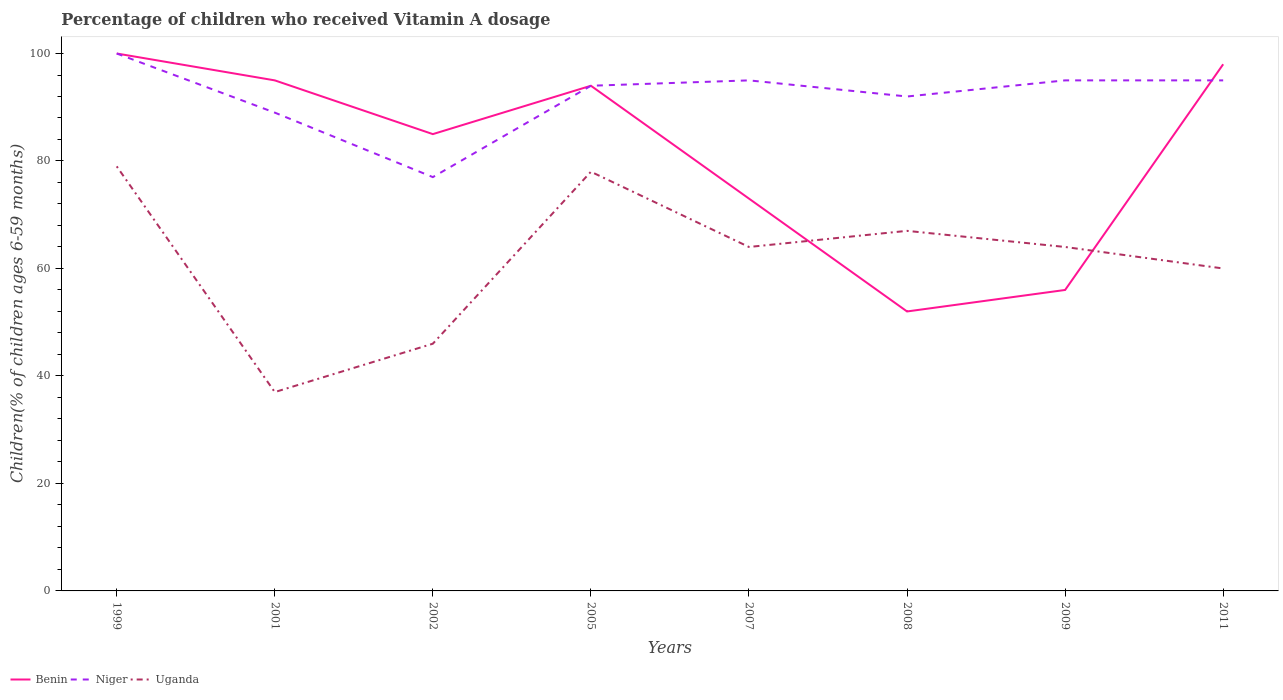How many different coloured lines are there?
Provide a succinct answer. 3. Does the line corresponding to Niger intersect with the line corresponding to Uganda?
Give a very brief answer. No. Is the number of lines equal to the number of legend labels?
Ensure brevity in your answer.  Yes. In which year was the percentage of children who received Vitamin A dosage in Niger maximum?
Ensure brevity in your answer.  2002. How many lines are there?
Your answer should be very brief. 3. How many years are there in the graph?
Offer a terse response. 8. Does the graph contain any zero values?
Your answer should be compact. No. Does the graph contain grids?
Provide a succinct answer. No. How are the legend labels stacked?
Make the answer very short. Horizontal. What is the title of the graph?
Make the answer very short. Percentage of children who received Vitamin A dosage. Does "Chad" appear as one of the legend labels in the graph?
Give a very brief answer. No. What is the label or title of the Y-axis?
Provide a short and direct response. Children(% of children ages 6-59 months). What is the Children(% of children ages 6-59 months) of Benin in 1999?
Your answer should be compact. 100. What is the Children(% of children ages 6-59 months) of Uganda in 1999?
Offer a very short reply. 79. What is the Children(% of children ages 6-59 months) of Benin in 2001?
Offer a very short reply. 95. What is the Children(% of children ages 6-59 months) in Niger in 2001?
Offer a terse response. 89. What is the Children(% of children ages 6-59 months) of Uganda in 2001?
Make the answer very short. 37. What is the Children(% of children ages 6-59 months) in Benin in 2002?
Keep it short and to the point. 85. What is the Children(% of children ages 6-59 months) of Niger in 2002?
Offer a very short reply. 77. What is the Children(% of children ages 6-59 months) in Benin in 2005?
Give a very brief answer. 94. What is the Children(% of children ages 6-59 months) of Niger in 2005?
Provide a short and direct response. 94. What is the Children(% of children ages 6-59 months) in Benin in 2007?
Offer a terse response. 73. What is the Children(% of children ages 6-59 months) of Niger in 2008?
Your answer should be compact. 92. What is the Children(% of children ages 6-59 months) in Uganda in 2008?
Your response must be concise. 67. What is the Children(% of children ages 6-59 months) of Benin in 2011?
Provide a short and direct response. 98. What is the Children(% of children ages 6-59 months) in Niger in 2011?
Offer a very short reply. 95. Across all years, what is the maximum Children(% of children ages 6-59 months) in Benin?
Offer a terse response. 100. Across all years, what is the maximum Children(% of children ages 6-59 months) of Niger?
Your answer should be very brief. 100. Across all years, what is the maximum Children(% of children ages 6-59 months) of Uganda?
Offer a terse response. 79. Across all years, what is the minimum Children(% of children ages 6-59 months) in Benin?
Keep it short and to the point. 52. Across all years, what is the minimum Children(% of children ages 6-59 months) in Niger?
Give a very brief answer. 77. What is the total Children(% of children ages 6-59 months) in Benin in the graph?
Your answer should be very brief. 653. What is the total Children(% of children ages 6-59 months) of Niger in the graph?
Ensure brevity in your answer.  737. What is the total Children(% of children ages 6-59 months) in Uganda in the graph?
Keep it short and to the point. 495. What is the difference between the Children(% of children ages 6-59 months) of Benin in 1999 and that in 2001?
Ensure brevity in your answer.  5. What is the difference between the Children(% of children ages 6-59 months) in Niger in 1999 and that in 2002?
Offer a very short reply. 23. What is the difference between the Children(% of children ages 6-59 months) of Niger in 1999 and that in 2005?
Ensure brevity in your answer.  6. What is the difference between the Children(% of children ages 6-59 months) of Uganda in 1999 and that in 2007?
Your answer should be compact. 15. What is the difference between the Children(% of children ages 6-59 months) in Niger in 1999 and that in 2008?
Give a very brief answer. 8. What is the difference between the Children(% of children ages 6-59 months) in Uganda in 1999 and that in 2008?
Make the answer very short. 12. What is the difference between the Children(% of children ages 6-59 months) in Niger in 1999 and that in 2009?
Your answer should be very brief. 5. What is the difference between the Children(% of children ages 6-59 months) of Niger in 1999 and that in 2011?
Provide a succinct answer. 5. What is the difference between the Children(% of children ages 6-59 months) of Uganda in 1999 and that in 2011?
Your answer should be very brief. 19. What is the difference between the Children(% of children ages 6-59 months) in Uganda in 2001 and that in 2005?
Provide a short and direct response. -41. What is the difference between the Children(% of children ages 6-59 months) in Benin in 2001 and that in 2007?
Ensure brevity in your answer.  22. What is the difference between the Children(% of children ages 6-59 months) in Niger in 2001 and that in 2007?
Make the answer very short. -6. What is the difference between the Children(% of children ages 6-59 months) of Benin in 2001 and that in 2008?
Provide a succinct answer. 43. What is the difference between the Children(% of children ages 6-59 months) of Niger in 2001 and that in 2008?
Your response must be concise. -3. What is the difference between the Children(% of children ages 6-59 months) of Benin in 2001 and that in 2009?
Provide a succinct answer. 39. What is the difference between the Children(% of children ages 6-59 months) in Niger in 2001 and that in 2009?
Offer a terse response. -6. What is the difference between the Children(% of children ages 6-59 months) of Uganda in 2001 and that in 2009?
Provide a short and direct response. -27. What is the difference between the Children(% of children ages 6-59 months) in Uganda in 2001 and that in 2011?
Ensure brevity in your answer.  -23. What is the difference between the Children(% of children ages 6-59 months) of Niger in 2002 and that in 2005?
Your answer should be compact. -17. What is the difference between the Children(% of children ages 6-59 months) of Uganda in 2002 and that in 2005?
Provide a short and direct response. -32. What is the difference between the Children(% of children ages 6-59 months) of Benin in 2002 and that in 2007?
Your response must be concise. 12. What is the difference between the Children(% of children ages 6-59 months) of Uganda in 2002 and that in 2007?
Keep it short and to the point. -18. What is the difference between the Children(% of children ages 6-59 months) of Niger in 2002 and that in 2008?
Provide a succinct answer. -15. What is the difference between the Children(% of children ages 6-59 months) of Uganda in 2002 and that in 2008?
Offer a very short reply. -21. What is the difference between the Children(% of children ages 6-59 months) of Benin in 2002 and that in 2009?
Offer a very short reply. 29. What is the difference between the Children(% of children ages 6-59 months) in Benin in 2002 and that in 2011?
Your answer should be very brief. -13. What is the difference between the Children(% of children ages 6-59 months) in Niger in 2002 and that in 2011?
Provide a short and direct response. -18. What is the difference between the Children(% of children ages 6-59 months) of Uganda in 2002 and that in 2011?
Ensure brevity in your answer.  -14. What is the difference between the Children(% of children ages 6-59 months) in Niger in 2005 and that in 2007?
Keep it short and to the point. -1. What is the difference between the Children(% of children ages 6-59 months) in Uganda in 2005 and that in 2007?
Offer a terse response. 14. What is the difference between the Children(% of children ages 6-59 months) in Benin in 2005 and that in 2008?
Your answer should be very brief. 42. What is the difference between the Children(% of children ages 6-59 months) of Niger in 2005 and that in 2008?
Provide a succinct answer. 2. What is the difference between the Children(% of children ages 6-59 months) in Uganda in 2005 and that in 2009?
Offer a terse response. 14. What is the difference between the Children(% of children ages 6-59 months) in Benin in 2005 and that in 2011?
Offer a very short reply. -4. What is the difference between the Children(% of children ages 6-59 months) in Uganda in 2005 and that in 2011?
Your answer should be very brief. 18. What is the difference between the Children(% of children ages 6-59 months) in Niger in 2008 and that in 2009?
Your answer should be compact. -3. What is the difference between the Children(% of children ages 6-59 months) in Uganda in 2008 and that in 2009?
Your answer should be compact. 3. What is the difference between the Children(% of children ages 6-59 months) in Benin in 2008 and that in 2011?
Provide a succinct answer. -46. What is the difference between the Children(% of children ages 6-59 months) of Niger in 2008 and that in 2011?
Ensure brevity in your answer.  -3. What is the difference between the Children(% of children ages 6-59 months) of Benin in 2009 and that in 2011?
Your response must be concise. -42. What is the difference between the Children(% of children ages 6-59 months) in Uganda in 2009 and that in 2011?
Offer a very short reply. 4. What is the difference between the Children(% of children ages 6-59 months) of Benin in 1999 and the Children(% of children ages 6-59 months) of Uganda in 2001?
Offer a very short reply. 63. What is the difference between the Children(% of children ages 6-59 months) of Benin in 1999 and the Children(% of children ages 6-59 months) of Niger in 2002?
Offer a terse response. 23. What is the difference between the Children(% of children ages 6-59 months) in Benin in 1999 and the Children(% of children ages 6-59 months) in Uganda in 2002?
Your answer should be compact. 54. What is the difference between the Children(% of children ages 6-59 months) in Niger in 1999 and the Children(% of children ages 6-59 months) in Uganda in 2002?
Your response must be concise. 54. What is the difference between the Children(% of children ages 6-59 months) of Benin in 1999 and the Children(% of children ages 6-59 months) of Uganda in 2005?
Ensure brevity in your answer.  22. What is the difference between the Children(% of children ages 6-59 months) in Niger in 1999 and the Children(% of children ages 6-59 months) in Uganda in 2005?
Your answer should be compact. 22. What is the difference between the Children(% of children ages 6-59 months) of Benin in 1999 and the Children(% of children ages 6-59 months) of Niger in 2007?
Give a very brief answer. 5. What is the difference between the Children(% of children ages 6-59 months) in Niger in 1999 and the Children(% of children ages 6-59 months) in Uganda in 2007?
Make the answer very short. 36. What is the difference between the Children(% of children ages 6-59 months) of Benin in 1999 and the Children(% of children ages 6-59 months) of Uganda in 2008?
Provide a short and direct response. 33. What is the difference between the Children(% of children ages 6-59 months) in Benin in 1999 and the Children(% of children ages 6-59 months) in Uganda in 2009?
Your response must be concise. 36. What is the difference between the Children(% of children ages 6-59 months) of Niger in 1999 and the Children(% of children ages 6-59 months) of Uganda in 2009?
Your answer should be very brief. 36. What is the difference between the Children(% of children ages 6-59 months) in Benin in 1999 and the Children(% of children ages 6-59 months) in Uganda in 2011?
Provide a succinct answer. 40. What is the difference between the Children(% of children ages 6-59 months) in Niger in 1999 and the Children(% of children ages 6-59 months) in Uganda in 2011?
Your answer should be very brief. 40. What is the difference between the Children(% of children ages 6-59 months) of Niger in 2001 and the Children(% of children ages 6-59 months) of Uganda in 2002?
Make the answer very short. 43. What is the difference between the Children(% of children ages 6-59 months) in Benin in 2001 and the Children(% of children ages 6-59 months) in Niger in 2005?
Give a very brief answer. 1. What is the difference between the Children(% of children ages 6-59 months) in Niger in 2001 and the Children(% of children ages 6-59 months) in Uganda in 2005?
Offer a very short reply. 11. What is the difference between the Children(% of children ages 6-59 months) of Benin in 2001 and the Children(% of children ages 6-59 months) of Niger in 2007?
Ensure brevity in your answer.  0. What is the difference between the Children(% of children ages 6-59 months) of Benin in 2001 and the Children(% of children ages 6-59 months) of Uganda in 2007?
Your answer should be compact. 31. What is the difference between the Children(% of children ages 6-59 months) of Benin in 2001 and the Children(% of children ages 6-59 months) of Uganda in 2008?
Your response must be concise. 28. What is the difference between the Children(% of children ages 6-59 months) in Benin in 2001 and the Children(% of children ages 6-59 months) in Niger in 2011?
Offer a terse response. 0. What is the difference between the Children(% of children ages 6-59 months) in Benin in 2002 and the Children(% of children ages 6-59 months) in Niger in 2005?
Your answer should be compact. -9. What is the difference between the Children(% of children ages 6-59 months) in Benin in 2002 and the Children(% of children ages 6-59 months) in Uganda in 2005?
Your response must be concise. 7. What is the difference between the Children(% of children ages 6-59 months) in Benin in 2002 and the Children(% of children ages 6-59 months) in Uganda in 2007?
Provide a succinct answer. 21. What is the difference between the Children(% of children ages 6-59 months) in Benin in 2002 and the Children(% of children ages 6-59 months) in Niger in 2008?
Your answer should be very brief. -7. What is the difference between the Children(% of children ages 6-59 months) in Niger in 2002 and the Children(% of children ages 6-59 months) in Uganda in 2008?
Keep it short and to the point. 10. What is the difference between the Children(% of children ages 6-59 months) of Benin in 2002 and the Children(% of children ages 6-59 months) of Niger in 2009?
Provide a succinct answer. -10. What is the difference between the Children(% of children ages 6-59 months) in Benin in 2002 and the Children(% of children ages 6-59 months) in Uganda in 2009?
Give a very brief answer. 21. What is the difference between the Children(% of children ages 6-59 months) of Niger in 2002 and the Children(% of children ages 6-59 months) of Uganda in 2009?
Make the answer very short. 13. What is the difference between the Children(% of children ages 6-59 months) in Benin in 2002 and the Children(% of children ages 6-59 months) in Uganda in 2011?
Offer a terse response. 25. What is the difference between the Children(% of children ages 6-59 months) of Benin in 2005 and the Children(% of children ages 6-59 months) of Niger in 2008?
Ensure brevity in your answer.  2. What is the difference between the Children(% of children ages 6-59 months) of Benin in 2005 and the Children(% of children ages 6-59 months) of Niger in 2009?
Keep it short and to the point. -1. What is the difference between the Children(% of children ages 6-59 months) in Benin in 2005 and the Children(% of children ages 6-59 months) in Uganda in 2011?
Offer a very short reply. 34. What is the difference between the Children(% of children ages 6-59 months) in Benin in 2007 and the Children(% of children ages 6-59 months) in Uganda in 2008?
Keep it short and to the point. 6. What is the difference between the Children(% of children ages 6-59 months) in Niger in 2007 and the Children(% of children ages 6-59 months) in Uganda in 2008?
Your answer should be compact. 28. What is the difference between the Children(% of children ages 6-59 months) in Benin in 2007 and the Children(% of children ages 6-59 months) in Niger in 2009?
Make the answer very short. -22. What is the difference between the Children(% of children ages 6-59 months) in Benin in 2007 and the Children(% of children ages 6-59 months) in Uganda in 2011?
Provide a short and direct response. 13. What is the difference between the Children(% of children ages 6-59 months) in Benin in 2008 and the Children(% of children ages 6-59 months) in Niger in 2009?
Make the answer very short. -43. What is the difference between the Children(% of children ages 6-59 months) in Niger in 2008 and the Children(% of children ages 6-59 months) in Uganda in 2009?
Your answer should be compact. 28. What is the difference between the Children(% of children ages 6-59 months) of Benin in 2008 and the Children(% of children ages 6-59 months) of Niger in 2011?
Your answer should be very brief. -43. What is the difference between the Children(% of children ages 6-59 months) in Benin in 2008 and the Children(% of children ages 6-59 months) in Uganda in 2011?
Your answer should be very brief. -8. What is the difference between the Children(% of children ages 6-59 months) in Benin in 2009 and the Children(% of children ages 6-59 months) in Niger in 2011?
Provide a succinct answer. -39. What is the difference between the Children(% of children ages 6-59 months) of Benin in 2009 and the Children(% of children ages 6-59 months) of Uganda in 2011?
Offer a terse response. -4. What is the average Children(% of children ages 6-59 months) in Benin per year?
Make the answer very short. 81.62. What is the average Children(% of children ages 6-59 months) in Niger per year?
Ensure brevity in your answer.  92.12. What is the average Children(% of children ages 6-59 months) of Uganda per year?
Make the answer very short. 61.88. In the year 1999, what is the difference between the Children(% of children ages 6-59 months) of Benin and Children(% of children ages 6-59 months) of Uganda?
Your answer should be compact. 21. In the year 2001, what is the difference between the Children(% of children ages 6-59 months) of Benin and Children(% of children ages 6-59 months) of Uganda?
Keep it short and to the point. 58. In the year 2002, what is the difference between the Children(% of children ages 6-59 months) in Benin and Children(% of children ages 6-59 months) in Niger?
Your answer should be very brief. 8. In the year 2005, what is the difference between the Children(% of children ages 6-59 months) of Benin and Children(% of children ages 6-59 months) of Niger?
Keep it short and to the point. 0. In the year 2008, what is the difference between the Children(% of children ages 6-59 months) of Niger and Children(% of children ages 6-59 months) of Uganda?
Your answer should be compact. 25. In the year 2009, what is the difference between the Children(% of children ages 6-59 months) of Benin and Children(% of children ages 6-59 months) of Niger?
Your response must be concise. -39. In the year 2009, what is the difference between the Children(% of children ages 6-59 months) of Benin and Children(% of children ages 6-59 months) of Uganda?
Ensure brevity in your answer.  -8. In the year 2011, what is the difference between the Children(% of children ages 6-59 months) of Benin and Children(% of children ages 6-59 months) of Uganda?
Offer a terse response. 38. What is the ratio of the Children(% of children ages 6-59 months) in Benin in 1999 to that in 2001?
Your answer should be very brief. 1.05. What is the ratio of the Children(% of children ages 6-59 months) in Niger in 1999 to that in 2001?
Make the answer very short. 1.12. What is the ratio of the Children(% of children ages 6-59 months) of Uganda in 1999 to that in 2001?
Your response must be concise. 2.14. What is the ratio of the Children(% of children ages 6-59 months) of Benin in 1999 to that in 2002?
Provide a succinct answer. 1.18. What is the ratio of the Children(% of children ages 6-59 months) in Niger in 1999 to that in 2002?
Your response must be concise. 1.3. What is the ratio of the Children(% of children ages 6-59 months) of Uganda in 1999 to that in 2002?
Your response must be concise. 1.72. What is the ratio of the Children(% of children ages 6-59 months) in Benin in 1999 to that in 2005?
Ensure brevity in your answer.  1.06. What is the ratio of the Children(% of children ages 6-59 months) of Niger in 1999 to that in 2005?
Give a very brief answer. 1.06. What is the ratio of the Children(% of children ages 6-59 months) in Uganda in 1999 to that in 2005?
Keep it short and to the point. 1.01. What is the ratio of the Children(% of children ages 6-59 months) of Benin in 1999 to that in 2007?
Make the answer very short. 1.37. What is the ratio of the Children(% of children ages 6-59 months) in Niger in 1999 to that in 2007?
Offer a very short reply. 1.05. What is the ratio of the Children(% of children ages 6-59 months) of Uganda in 1999 to that in 2007?
Give a very brief answer. 1.23. What is the ratio of the Children(% of children ages 6-59 months) of Benin in 1999 to that in 2008?
Provide a short and direct response. 1.92. What is the ratio of the Children(% of children ages 6-59 months) in Niger in 1999 to that in 2008?
Offer a very short reply. 1.09. What is the ratio of the Children(% of children ages 6-59 months) in Uganda in 1999 to that in 2008?
Your response must be concise. 1.18. What is the ratio of the Children(% of children ages 6-59 months) of Benin in 1999 to that in 2009?
Ensure brevity in your answer.  1.79. What is the ratio of the Children(% of children ages 6-59 months) of Niger in 1999 to that in 2009?
Ensure brevity in your answer.  1.05. What is the ratio of the Children(% of children ages 6-59 months) of Uganda in 1999 to that in 2009?
Your answer should be very brief. 1.23. What is the ratio of the Children(% of children ages 6-59 months) of Benin in 1999 to that in 2011?
Give a very brief answer. 1.02. What is the ratio of the Children(% of children ages 6-59 months) of Niger in 1999 to that in 2011?
Your answer should be compact. 1.05. What is the ratio of the Children(% of children ages 6-59 months) of Uganda in 1999 to that in 2011?
Provide a short and direct response. 1.32. What is the ratio of the Children(% of children ages 6-59 months) in Benin in 2001 to that in 2002?
Ensure brevity in your answer.  1.12. What is the ratio of the Children(% of children ages 6-59 months) in Niger in 2001 to that in 2002?
Give a very brief answer. 1.16. What is the ratio of the Children(% of children ages 6-59 months) of Uganda in 2001 to that in 2002?
Provide a short and direct response. 0.8. What is the ratio of the Children(% of children ages 6-59 months) in Benin in 2001 to that in 2005?
Keep it short and to the point. 1.01. What is the ratio of the Children(% of children ages 6-59 months) in Niger in 2001 to that in 2005?
Provide a short and direct response. 0.95. What is the ratio of the Children(% of children ages 6-59 months) of Uganda in 2001 to that in 2005?
Keep it short and to the point. 0.47. What is the ratio of the Children(% of children ages 6-59 months) of Benin in 2001 to that in 2007?
Keep it short and to the point. 1.3. What is the ratio of the Children(% of children ages 6-59 months) in Niger in 2001 to that in 2007?
Offer a terse response. 0.94. What is the ratio of the Children(% of children ages 6-59 months) in Uganda in 2001 to that in 2007?
Offer a very short reply. 0.58. What is the ratio of the Children(% of children ages 6-59 months) in Benin in 2001 to that in 2008?
Offer a terse response. 1.83. What is the ratio of the Children(% of children ages 6-59 months) in Niger in 2001 to that in 2008?
Give a very brief answer. 0.97. What is the ratio of the Children(% of children ages 6-59 months) of Uganda in 2001 to that in 2008?
Your answer should be very brief. 0.55. What is the ratio of the Children(% of children ages 6-59 months) of Benin in 2001 to that in 2009?
Your response must be concise. 1.7. What is the ratio of the Children(% of children ages 6-59 months) in Niger in 2001 to that in 2009?
Provide a succinct answer. 0.94. What is the ratio of the Children(% of children ages 6-59 months) of Uganda in 2001 to that in 2009?
Offer a very short reply. 0.58. What is the ratio of the Children(% of children ages 6-59 months) of Benin in 2001 to that in 2011?
Offer a very short reply. 0.97. What is the ratio of the Children(% of children ages 6-59 months) of Niger in 2001 to that in 2011?
Offer a terse response. 0.94. What is the ratio of the Children(% of children ages 6-59 months) in Uganda in 2001 to that in 2011?
Provide a short and direct response. 0.62. What is the ratio of the Children(% of children ages 6-59 months) in Benin in 2002 to that in 2005?
Make the answer very short. 0.9. What is the ratio of the Children(% of children ages 6-59 months) in Niger in 2002 to that in 2005?
Provide a succinct answer. 0.82. What is the ratio of the Children(% of children ages 6-59 months) of Uganda in 2002 to that in 2005?
Make the answer very short. 0.59. What is the ratio of the Children(% of children ages 6-59 months) in Benin in 2002 to that in 2007?
Keep it short and to the point. 1.16. What is the ratio of the Children(% of children ages 6-59 months) of Niger in 2002 to that in 2007?
Offer a very short reply. 0.81. What is the ratio of the Children(% of children ages 6-59 months) in Uganda in 2002 to that in 2007?
Ensure brevity in your answer.  0.72. What is the ratio of the Children(% of children ages 6-59 months) of Benin in 2002 to that in 2008?
Offer a very short reply. 1.63. What is the ratio of the Children(% of children ages 6-59 months) in Niger in 2002 to that in 2008?
Make the answer very short. 0.84. What is the ratio of the Children(% of children ages 6-59 months) of Uganda in 2002 to that in 2008?
Your answer should be very brief. 0.69. What is the ratio of the Children(% of children ages 6-59 months) of Benin in 2002 to that in 2009?
Your response must be concise. 1.52. What is the ratio of the Children(% of children ages 6-59 months) of Niger in 2002 to that in 2009?
Keep it short and to the point. 0.81. What is the ratio of the Children(% of children ages 6-59 months) of Uganda in 2002 to that in 2009?
Provide a succinct answer. 0.72. What is the ratio of the Children(% of children ages 6-59 months) of Benin in 2002 to that in 2011?
Give a very brief answer. 0.87. What is the ratio of the Children(% of children ages 6-59 months) in Niger in 2002 to that in 2011?
Give a very brief answer. 0.81. What is the ratio of the Children(% of children ages 6-59 months) of Uganda in 2002 to that in 2011?
Your answer should be very brief. 0.77. What is the ratio of the Children(% of children ages 6-59 months) in Benin in 2005 to that in 2007?
Offer a terse response. 1.29. What is the ratio of the Children(% of children ages 6-59 months) in Uganda in 2005 to that in 2007?
Your answer should be very brief. 1.22. What is the ratio of the Children(% of children ages 6-59 months) of Benin in 2005 to that in 2008?
Your answer should be compact. 1.81. What is the ratio of the Children(% of children ages 6-59 months) in Niger in 2005 to that in 2008?
Offer a very short reply. 1.02. What is the ratio of the Children(% of children ages 6-59 months) of Uganda in 2005 to that in 2008?
Your answer should be compact. 1.16. What is the ratio of the Children(% of children ages 6-59 months) of Benin in 2005 to that in 2009?
Provide a short and direct response. 1.68. What is the ratio of the Children(% of children ages 6-59 months) in Niger in 2005 to that in 2009?
Give a very brief answer. 0.99. What is the ratio of the Children(% of children ages 6-59 months) in Uganda in 2005 to that in 2009?
Provide a short and direct response. 1.22. What is the ratio of the Children(% of children ages 6-59 months) in Benin in 2005 to that in 2011?
Give a very brief answer. 0.96. What is the ratio of the Children(% of children ages 6-59 months) of Niger in 2005 to that in 2011?
Your answer should be compact. 0.99. What is the ratio of the Children(% of children ages 6-59 months) of Benin in 2007 to that in 2008?
Provide a short and direct response. 1.4. What is the ratio of the Children(% of children ages 6-59 months) of Niger in 2007 to that in 2008?
Your answer should be compact. 1.03. What is the ratio of the Children(% of children ages 6-59 months) in Uganda in 2007 to that in 2008?
Give a very brief answer. 0.96. What is the ratio of the Children(% of children ages 6-59 months) of Benin in 2007 to that in 2009?
Give a very brief answer. 1.3. What is the ratio of the Children(% of children ages 6-59 months) of Uganda in 2007 to that in 2009?
Your answer should be very brief. 1. What is the ratio of the Children(% of children ages 6-59 months) in Benin in 2007 to that in 2011?
Provide a succinct answer. 0.74. What is the ratio of the Children(% of children ages 6-59 months) of Niger in 2007 to that in 2011?
Ensure brevity in your answer.  1. What is the ratio of the Children(% of children ages 6-59 months) of Uganda in 2007 to that in 2011?
Your response must be concise. 1.07. What is the ratio of the Children(% of children ages 6-59 months) of Benin in 2008 to that in 2009?
Keep it short and to the point. 0.93. What is the ratio of the Children(% of children ages 6-59 months) of Niger in 2008 to that in 2009?
Provide a succinct answer. 0.97. What is the ratio of the Children(% of children ages 6-59 months) in Uganda in 2008 to that in 2009?
Your response must be concise. 1.05. What is the ratio of the Children(% of children ages 6-59 months) of Benin in 2008 to that in 2011?
Provide a short and direct response. 0.53. What is the ratio of the Children(% of children ages 6-59 months) of Niger in 2008 to that in 2011?
Give a very brief answer. 0.97. What is the ratio of the Children(% of children ages 6-59 months) of Uganda in 2008 to that in 2011?
Offer a terse response. 1.12. What is the ratio of the Children(% of children ages 6-59 months) in Niger in 2009 to that in 2011?
Provide a short and direct response. 1. What is the ratio of the Children(% of children ages 6-59 months) of Uganda in 2009 to that in 2011?
Give a very brief answer. 1.07. What is the difference between the highest and the lowest Children(% of children ages 6-59 months) in Niger?
Ensure brevity in your answer.  23. What is the difference between the highest and the lowest Children(% of children ages 6-59 months) of Uganda?
Your answer should be very brief. 42. 